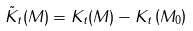Convert formula to latex. <formula><loc_0><loc_0><loc_500><loc_500>\tilde { K } _ { t } ( M ) = K _ { t } ( M ) - K _ { t } \left ( M _ { 0 } \right )</formula> 